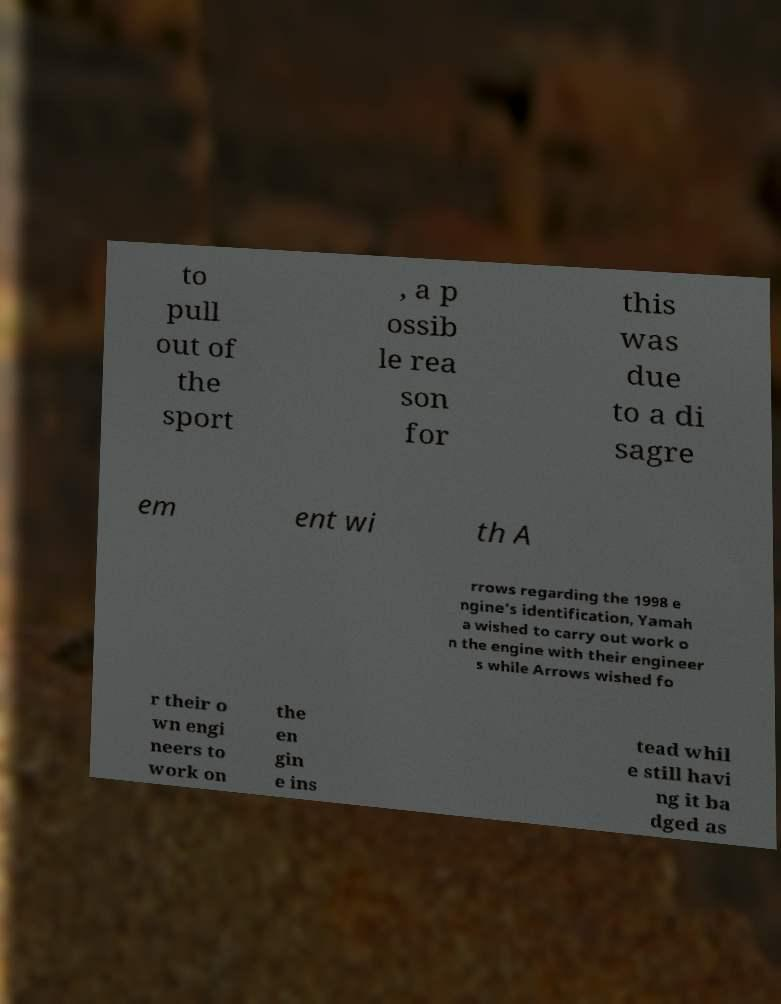I need the written content from this picture converted into text. Can you do that? to pull out of the sport , a p ossib le rea son for this was due to a di sagre em ent wi th A rrows regarding the 1998 e ngine's identification, Yamah a wished to carry out work o n the engine with their engineer s while Arrows wished fo r their o wn engi neers to work on the en gin e ins tead whil e still havi ng it ba dged as 